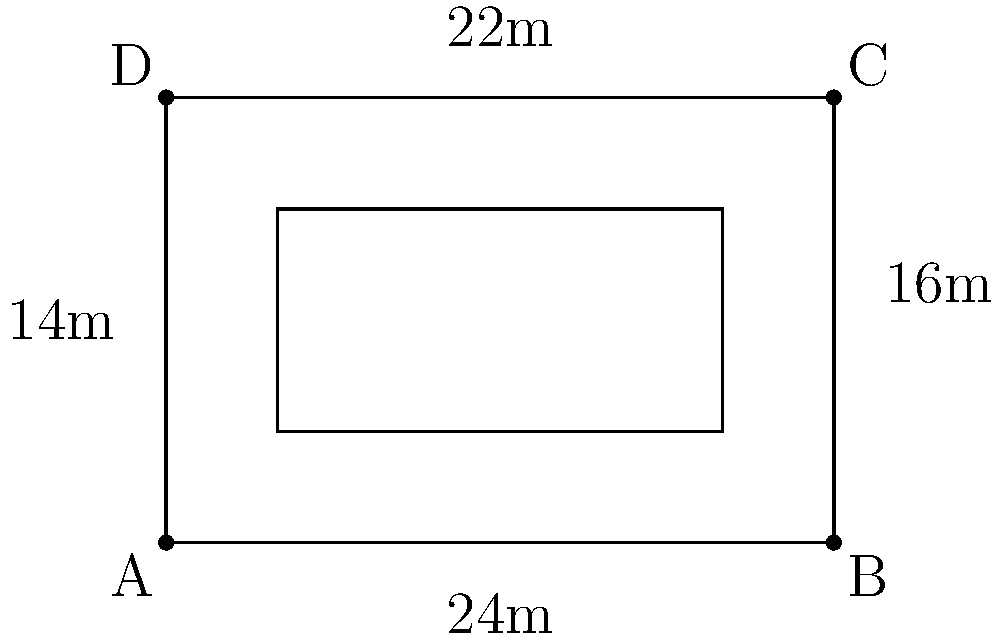As a civic technologist, you're tasked with optimizing the design of a new government building. The proposed building has a rectangular shape with an inner courtyard, as shown in the diagram. The outer dimensions are 24m x 16m, and the inner courtyard is 22m x 14m. What is the total floor area of the building, and how does this design impact construction costs compared to a solid rectangular building of the same outer dimensions? To solve this problem, we'll follow these steps:

1. Calculate the total area of the outer rectangle:
   $A_{outer} = 24m \times 16m = 384m^2$

2. Calculate the area of the inner courtyard:
   $A_{inner} = 22m \times 14m = 308m^2$

3. Calculate the actual floor area of the building:
   $A_{floor} = A_{outer} - A_{inner} = 384m^2 - 308m^2 = 76m^2$

4. Compare the floor area to a solid rectangular building:
   The solid rectangular building would have an area of $384m^2$, which is $308m^2$ more than the proposed design.

5. Impact on construction costs:
   a) The proposed design reduces the total floor area by 80.2% (308/384 = 0.802 or 80.2%).
   b) This significant reduction in floor area will lead to lower material costs for flooring, roofing, and interior finishes.
   c) However, the perimeter of the building remains the same, so exterior wall costs will be unchanged.
   d) The courtyard design may increase natural lighting and ventilation, potentially reducing energy costs.
   e) The open space can serve multiple purposes (e.g., gatherings, green space), adding value without additional construction costs.

In conclusion, while the proposed design significantly reduces the floor area and associated costs, it maintains the same exterior footprint and offers potential benefits in terms of functionality and energy efficiency. The overall impact on construction costs would be a substantial reduction compared to a solid rectangular building of the same outer dimensions.
Answer: Total floor area: $76m^2$. Reduces construction costs by eliminating 80.2% of floor area while maintaining exterior footprint and adding functional open space. 